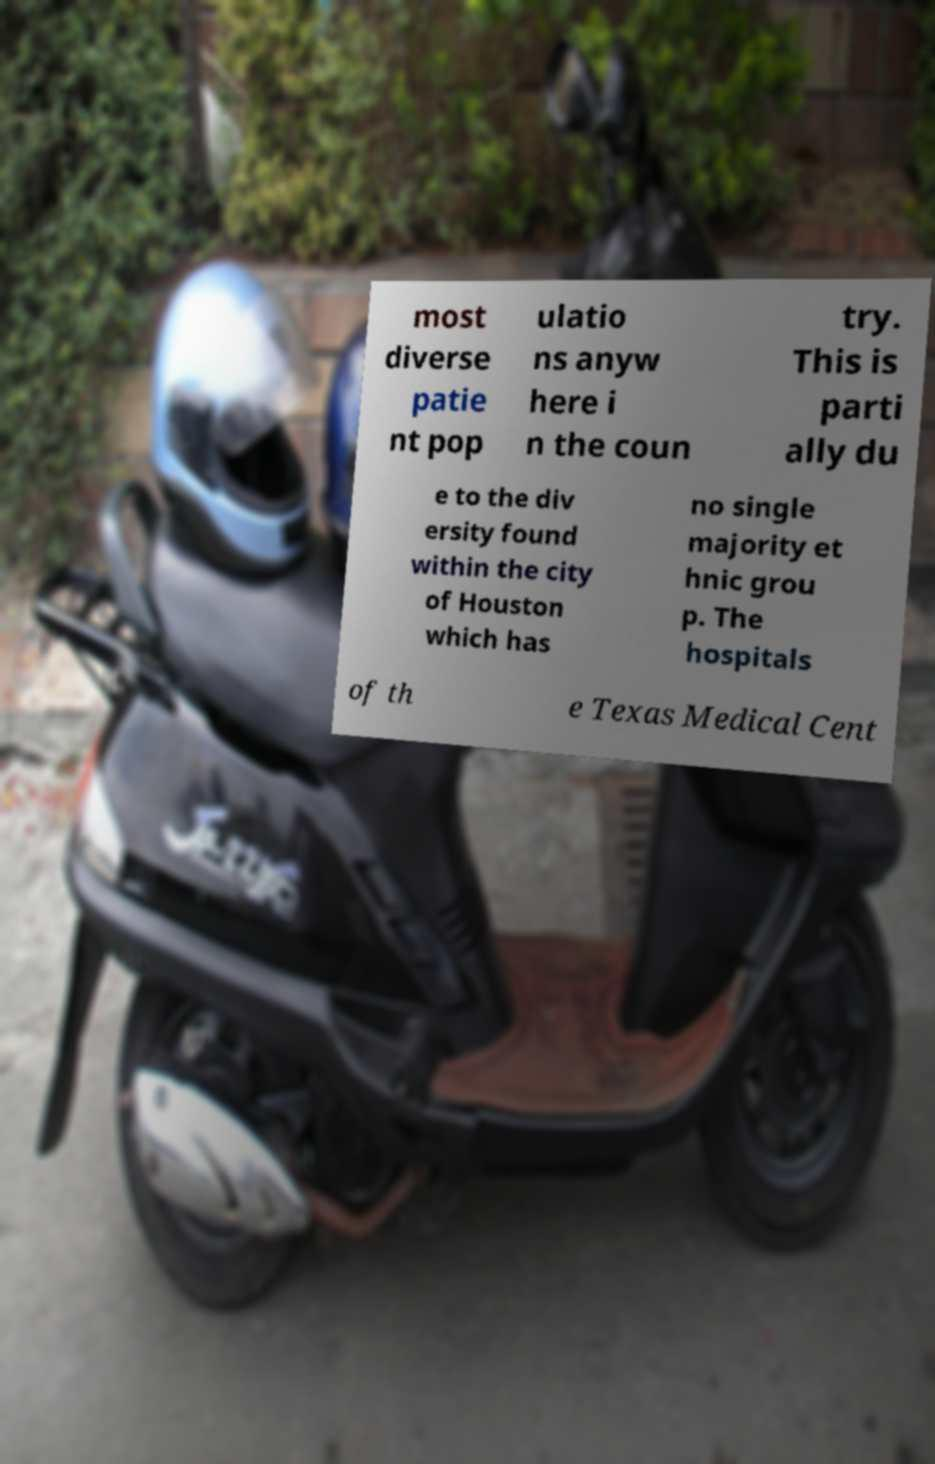Can you accurately transcribe the text from the provided image for me? most diverse patie nt pop ulatio ns anyw here i n the coun try. This is parti ally du e to the div ersity found within the city of Houston which has no single majority et hnic grou p. The hospitals of th e Texas Medical Cent 